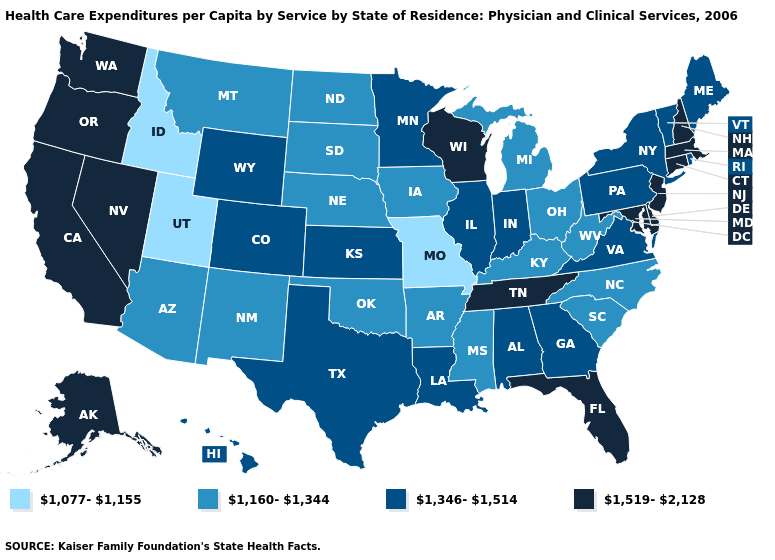How many symbols are there in the legend?
Write a very short answer. 4. Is the legend a continuous bar?
Answer briefly. No. Which states hav the highest value in the West?
Be succinct. Alaska, California, Nevada, Oregon, Washington. Does North Dakota have the highest value in the MidWest?
Give a very brief answer. No. What is the value of Massachusetts?
Short answer required. 1,519-2,128. What is the value of Nevada?
Answer briefly. 1,519-2,128. Does Virginia have the same value as New York?
Write a very short answer. Yes. What is the highest value in states that border Kansas?
Answer briefly. 1,346-1,514. Name the states that have a value in the range 1,160-1,344?
Answer briefly. Arizona, Arkansas, Iowa, Kentucky, Michigan, Mississippi, Montana, Nebraska, New Mexico, North Carolina, North Dakota, Ohio, Oklahoma, South Carolina, South Dakota, West Virginia. Which states have the highest value in the USA?
Give a very brief answer. Alaska, California, Connecticut, Delaware, Florida, Maryland, Massachusetts, Nevada, New Hampshire, New Jersey, Oregon, Tennessee, Washington, Wisconsin. Does Montana have a lower value than Ohio?
Write a very short answer. No. What is the value of South Carolina?
Short answer required. 1,160-1,344. Name the states that have a value in the range 1,077-1,155?
Be succinct. Idaho, Missouri, Utah. What is the lowest value in the USA?
Be succinct. 1,077-1,155. Name the states that have a value in the range 1,160-1,344?
Concise answer only. Arizona, Arkansas, Iowa, Kentucky, Michigan, Mississippi, Montana, Nebraska, New Mexico, North Carolina, North Dakota, Ohio, Oklahoma, South Carolina, South Dakota, West Virginia. 